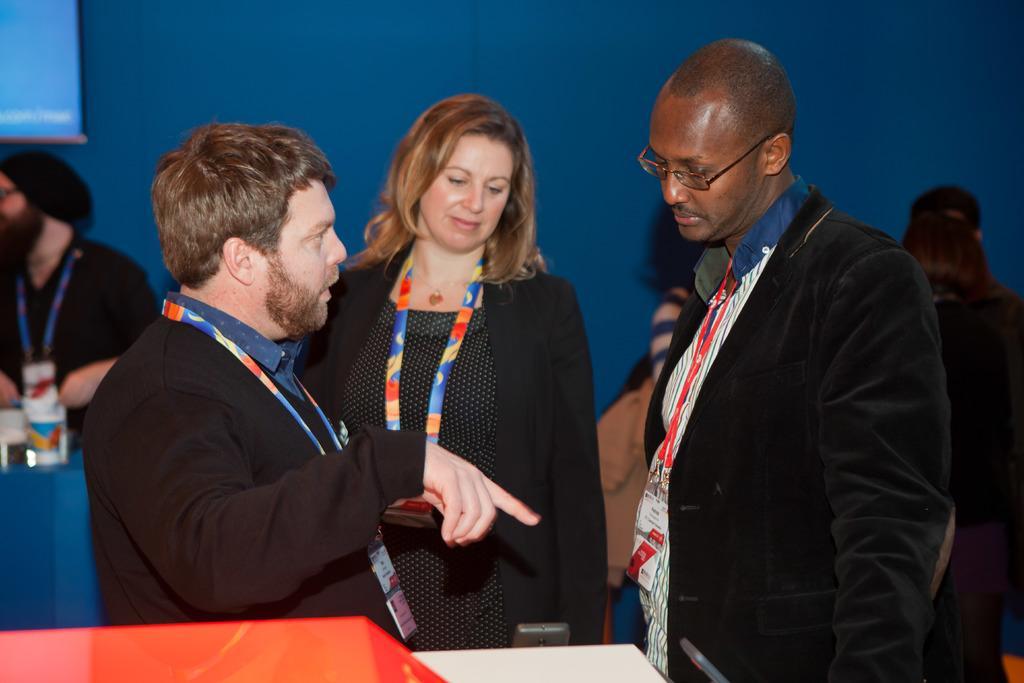Can you describe this image briefly? In this picture we can observe three members. Two of them are men and the other is woman wearing coat. All of them are wearing tags in their necks. In the background there are some people. We can observe a blue color wall. On the left side there is a projector display screen. 